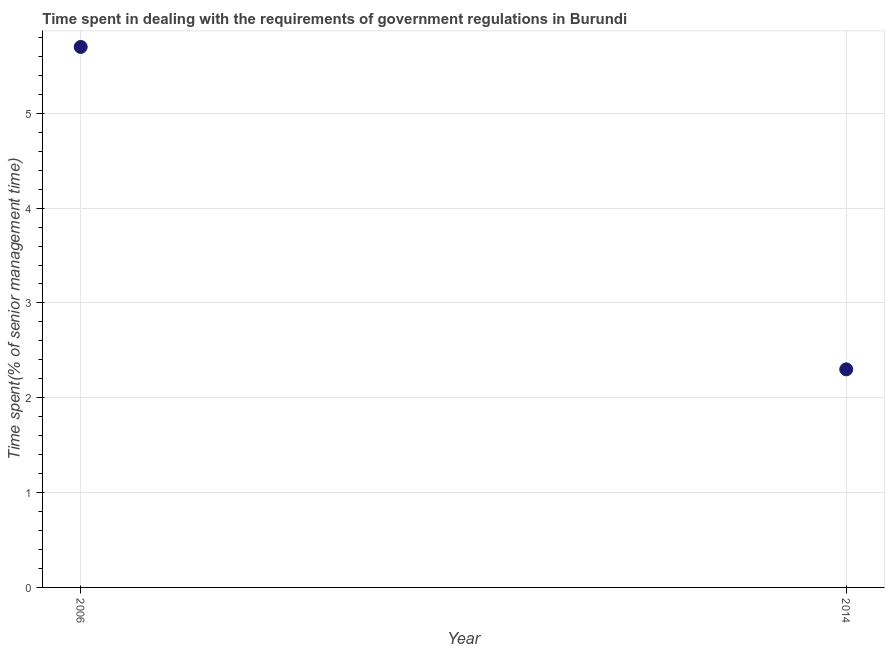Across all years, what is the minimum time spent in dealing with government regulations?
Give a very brief answer. 2.3. What is the sum of the time spent in dealing with government regulations?
Your response must be concise. 8. What is the difference between the time spent in dealing with government regulations in 2006 and 2014?
Your response must be concise. 3.4. What is the median time spent in dealing with government regulations?
Keep it short and to the point. 4. Do a majority of the years between 2006 and 2014 (inclusive) have time spent in dealing with government regulations greater than 3 %?
Make the answer very short. No. What is the ratio of the time spent in dealing with government regulations in 2006 to that in 2014?
Keep it short and to the point. 2.48. Does the time spent in dealing with government regulations monotonically increase over the years?
Ensure brevity in your answer.  No. How many dotlines are there?
Your answer should be compact. 1. Are the values on the major ticks of Y-axis written in scientific E-notation?
Provide a short and direct response. No. What is the title of the graph?
Provide a succinct answer. Time spent in dealing with the requirements of government regulations in Burundi. What is the label or title of the Y-axis?
Ensure brevity in your answer.  Time spent(% of senior management time). What is the difference between the Time spent(% of senior management time) in 2006 and 2014?
Offer a very short reply. 3.4. What is the ratio of the Time spent(% of senior management time) in 2006 to that in 2014?
Your answer should be compact. 2.48. 